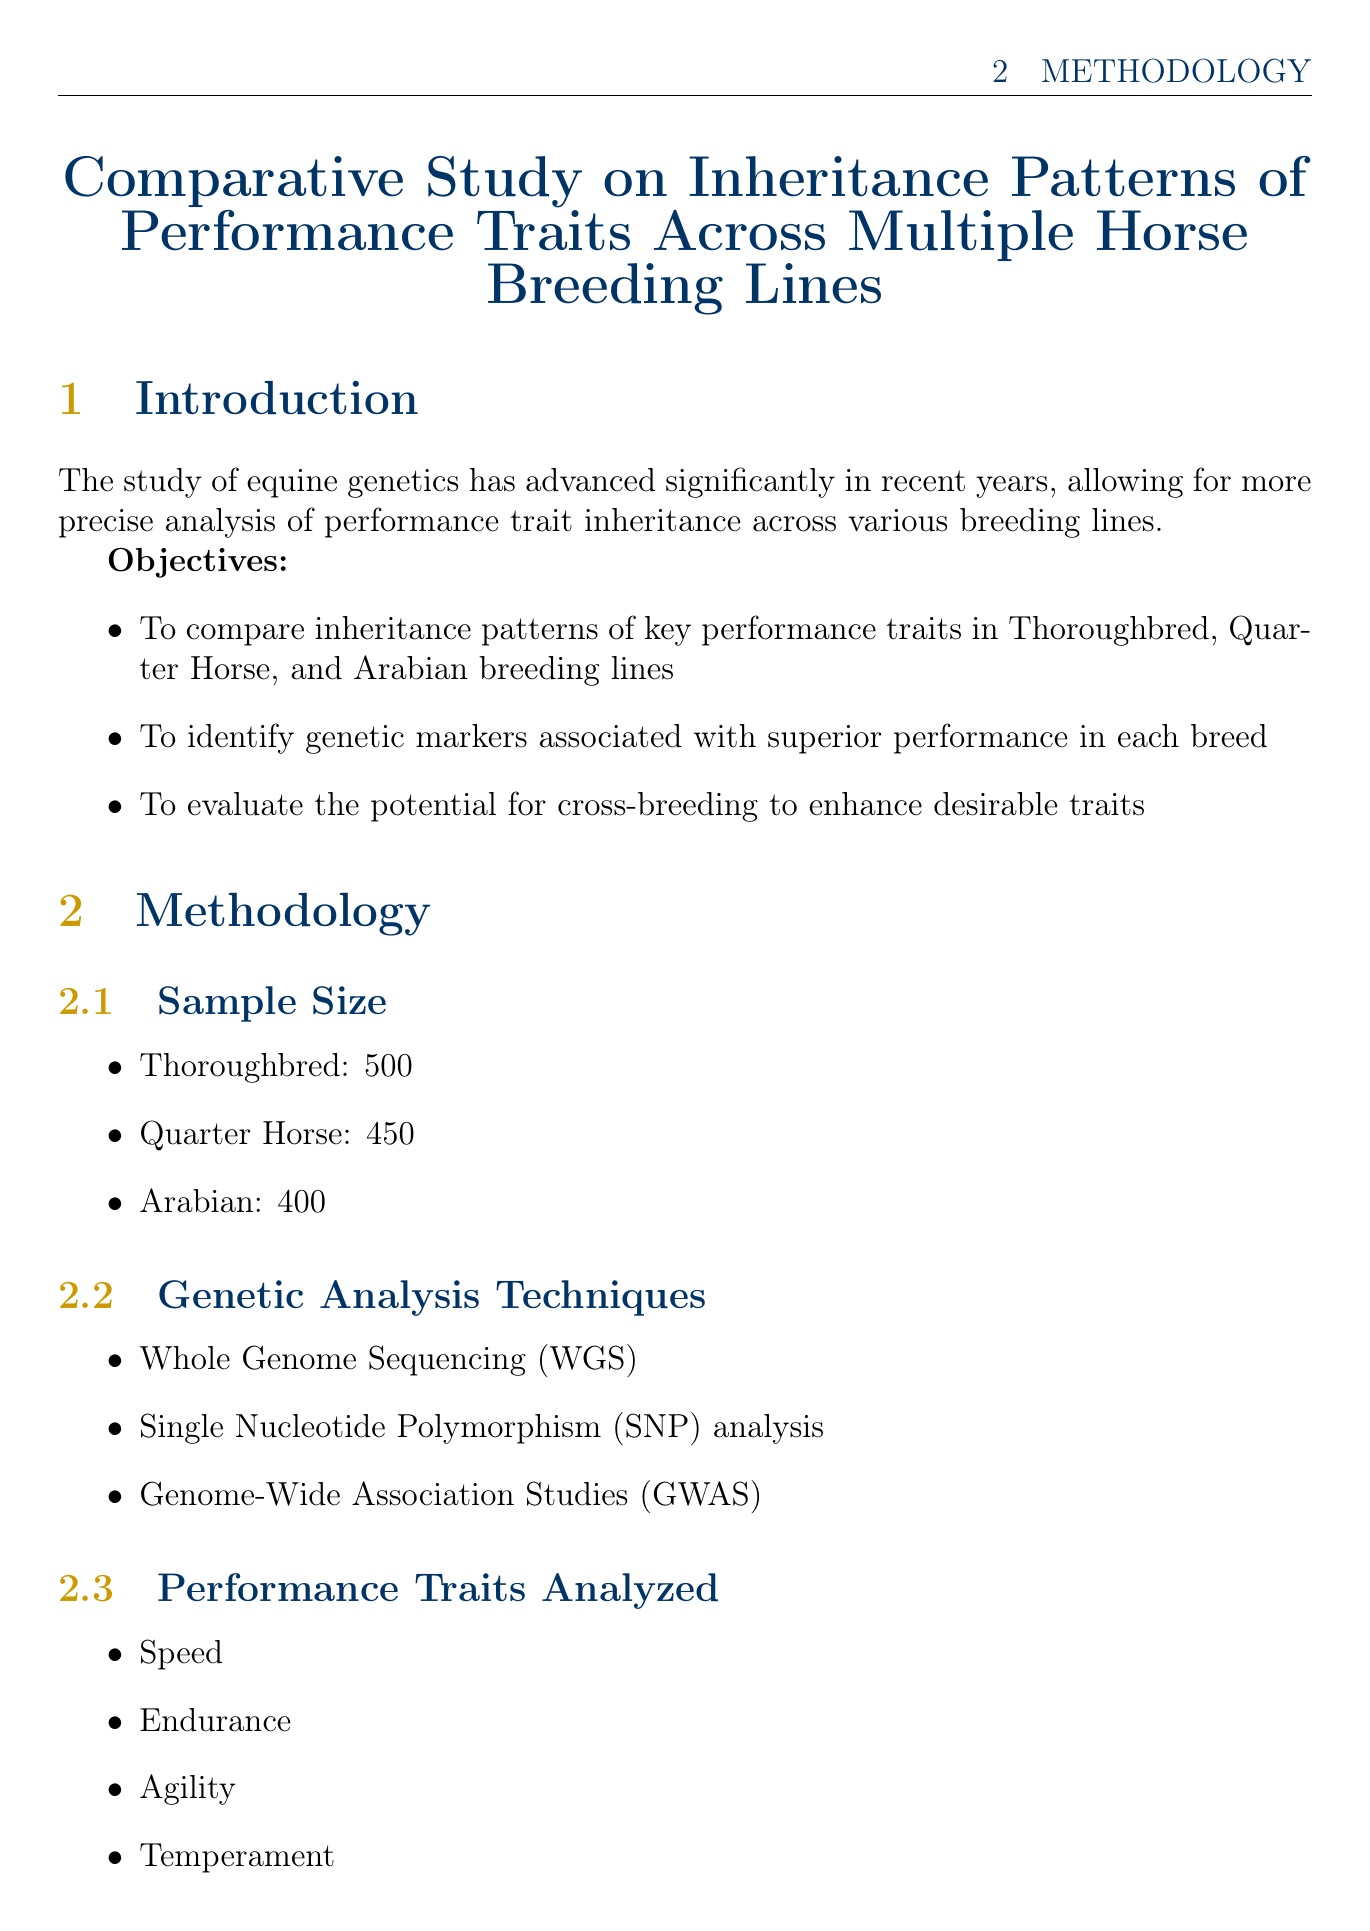What are the key performance traits analyzed? The document lists the performance traits analyzed as Speed, Endurance, Agility, and Temperament.
Answer: Speed, Endurance, Agility, Temperament What is the heritability estimate for speed in Quarter Horses? The document provides the heritability estimate for speed in Quarter Horses, which is 0.40.
Answer: 0.40 Which genetic analysis technique is listed first in the methodology? The first genetic analysis technique mentioned in the methodology section is Whole Genome Sequencing (WGS).
Answer: Whole Genome Sequencing (WGS) What is the sample size for Thoroughbreds? The document specifies the sample size for Thoroughbreds as 500.
Answer: 500 Which breed has a temperament heritability estimate? The heritability estimate for temperament is specifically mentioned for Arabians.
Answer: Arabians What genetic marker is associated with endurance in Arabians? The document identifies ACTN3 as a genetic marker associated with endurance in Arabians.
Answer: ACTN3 Which case study focuses on a Thoroughbred legend? The case study titled "Frankel: A Genetic Analysis of a Thoroughbred Legend" focuses on a Thoroughbred legend.
Answer: Frankel: A Genetic Analysis of a Thoroughbred Legend What is one unique finding about Tapit? The document mentions a strong heritability of performance traits in offspring as a unique finding about Tapit.
Answer: Strong heritability of performance traits in offspring 